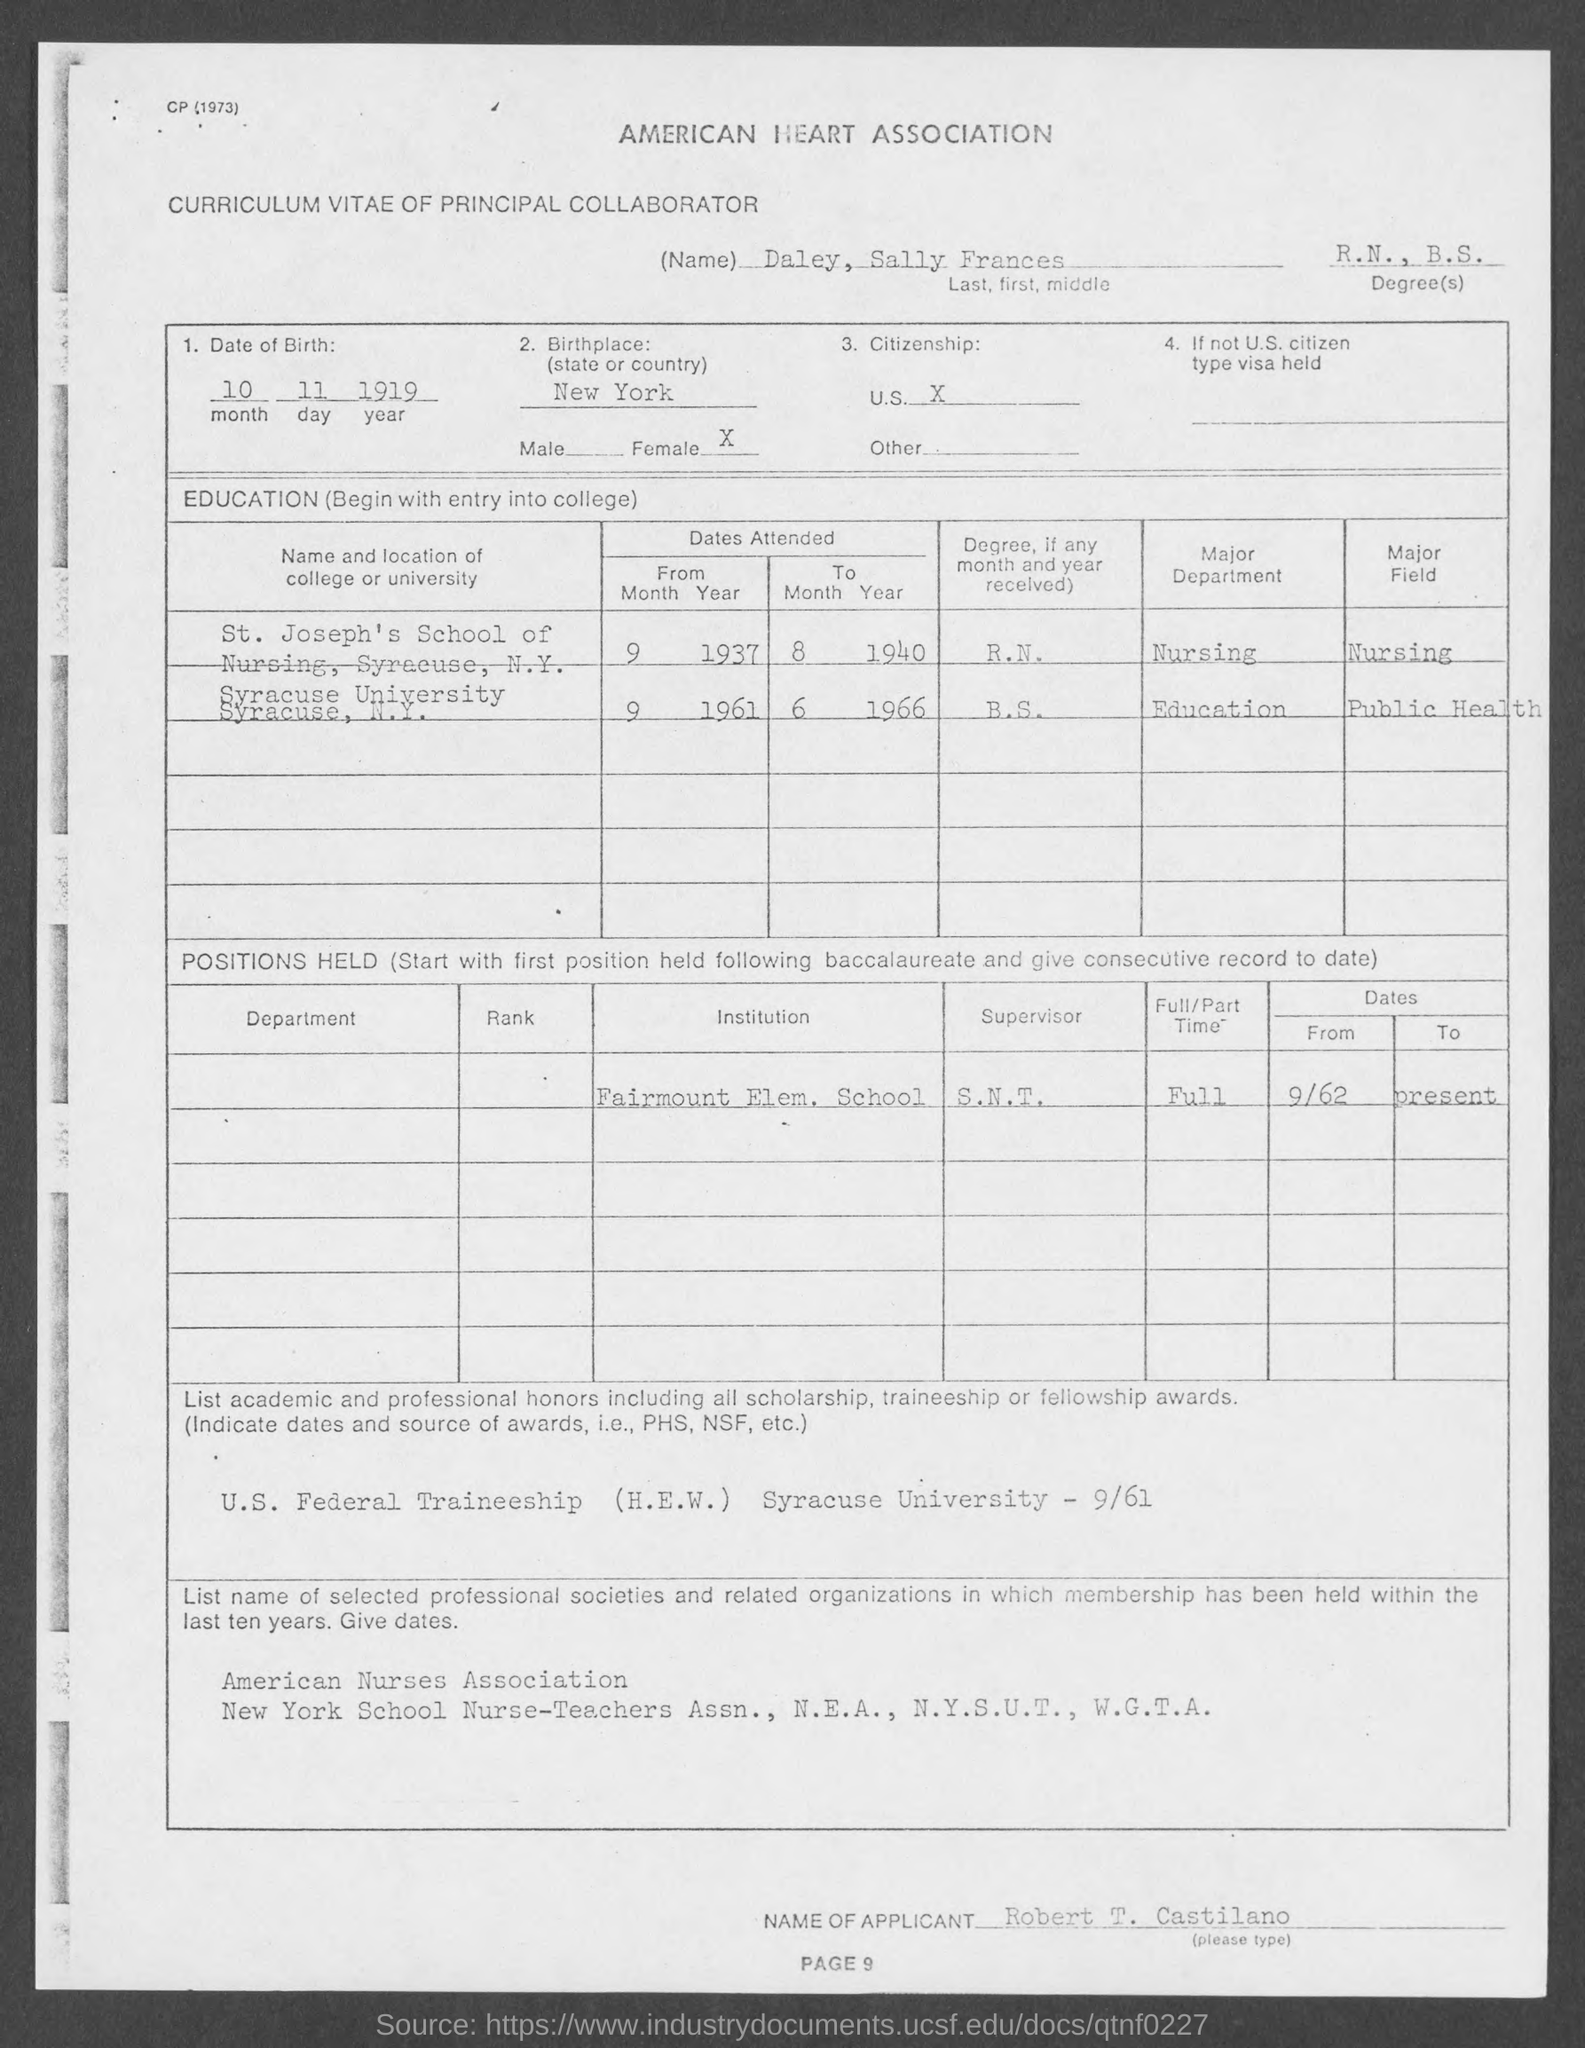Specify some key components in this picture. The name is Daley, Sally Frances. What is the Birthplace? It is New York. The date of birth of the individual is November 10, 1919. The title of the document is a Curriculum Vitae of a Principal Collaborator. What are the degrees? They are R.N., B.S.... 